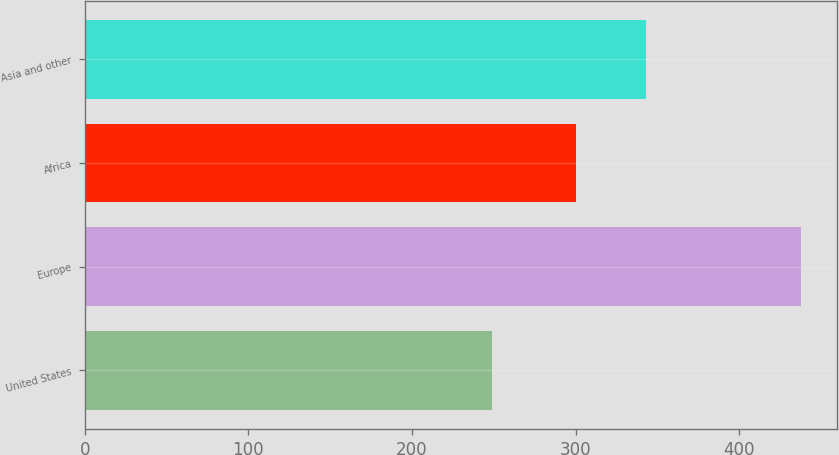Convert chart to OTSL. <chart><loc_0><loc_0><loc_500><loc_500><bar_chart><fcel>United States<fcel>Europe<fcel>Africa<fcel>Asia and other<nl><fcel>249<fcel>438<fcel>300<fcel>343<nl></chart> 